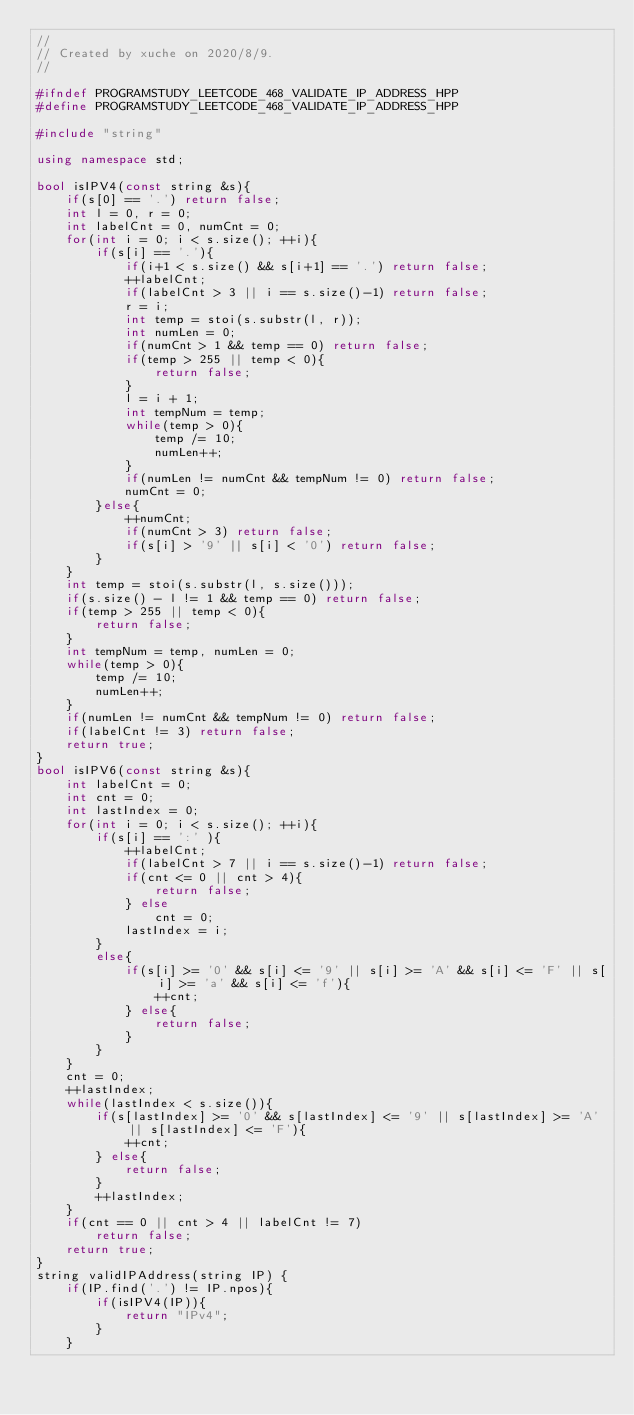<code> <loc_0><loc_0><loc_500><loc_500><_C++_>//
// Created by xuche on 2020/8/9.
//

#ifndef PROGRAMSTUDY_LEETCODE_468_VALIDATE_IP_ADDRESS_HPP
#define PROGRAMSTUDY_LEETCODE_468_VALIDATE_IP_ADDRESS_HPP

#include "string"

using namespace std;

bool isIPV4(const string &s){
    if(s[0] == '.') return false;
    int l = 0, r = 0;
    int labelCnt = 0, numCnt = 0;
    for(int i = 0; i < s.size(); ++i){
        if(s[i] == '.'){
            if(i+1 < s.size() && s[i+1] == '.') return false;
            ++labelCnt;
            if(labelCnt > 3 || i == s.size()-1) return false;
            r = i;
            int temp = stoi(s.substr(l, r));
            int numLen = 0;
            if(numCnt > 1 && temp == 0) return false;
            if(temp > 255 || temp < 0){
                return false;
            }
            l = i + 1;
            int tempNum = temp;
            while(temp > 0){
                temp /= 10;
                numLen++;
            }
            if(numLen != numCnt && tempNum != 0) return false;
            numCnt = 0;
        }else{
            ++numCnt;
            if(numCnt > 3) return false;
            if(s[i] > '9' || s[i] < '0') return false;
        }
    }
    int temp = stoi(s.substr(l, s.size()));
    if(s.size() - l != 1 && temp == 0) return false;
    if(temp > 255 || temp < 0){
        return false;
    }
    int tempNum = temp, numLen = 0;
    while(temp > 0){
        temp /= 10;
        numLen++;
    }
    if(numLen != numCnt && tempNum != 0) return false;
    if(labelCnt != 3) return false;
    return true;
}
bool isIPV6(const string &s){
    int labelCnt = 0;
    int cnt = 0;
    int lastIndex = 0;
    for(int i = 0; i < s.size(); ++i){
        if(s[i] == ':' ){
            ++labelCnt;
            if(labelCnt > 7 || i == s.size()-1) return false;
            if(cnt <= 0 || cnt > 4){
                return false;
            } else
                cnt = 0;
            lastIndex = i;
        }
        else{
            if(s[i] >= '0' && s[i] <= '9' || s[i] >= 'A' && s[i] <= 'F' || s[i] >= 'a' && s[i] <= 'f'){
                ++cnt;
            } else{
                return false;
            }
        }
    }
    cnt = 0;
    ++lastIndex;
    while(lastIndex < s.size()){
        if(s[lastIndex] >= '0' && s[lastIndex] <= '9' || s[lastIndex] >= 'A' || s[lastIndex] <= 'F'){
            ++cnt;
        } else{
            return false;
        }
        ++lastIndex;
    }
    if(cnt == 0 || cnt > 4 || labelCnt != 7)
        return false;
    return true;
}
string validIPAddress(string IP) {
    if(IP.find('.') != IP.npos){
        if(isIPV4(IP)){
            return "IPv4";
        }
    }</code> 